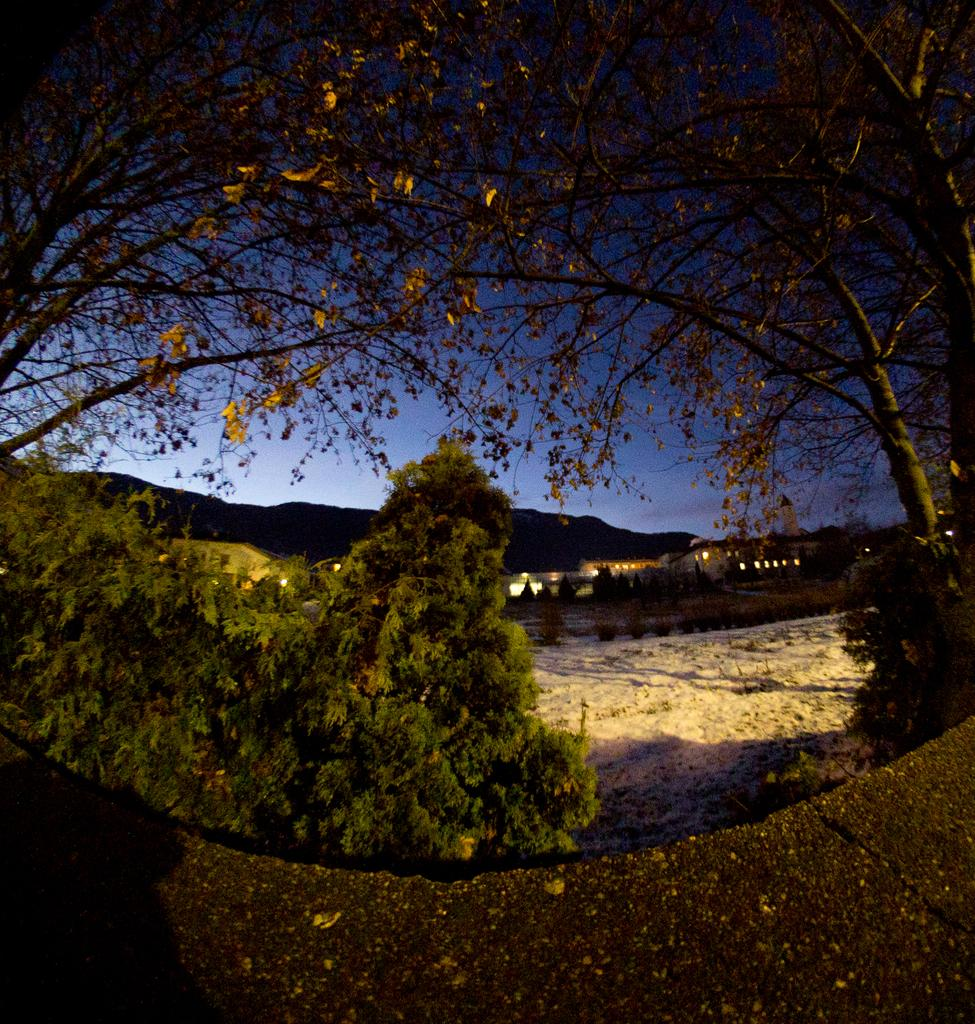What type of vegetation can be seen in the image? There is a plant and trees visible in the image. What structures can be seen in the background of the image? There is a building and lights visible in the background of the image. What natural features are present in the background of the image? There are mountains in the background of the image. What part of the natural environment is visible in the image? The sky is visible in the image, and clouds are present in the sky. What type of creature is interacting with the plant in the image? There is no creature present in the image; it only features a plant, trees, lights, a building, mountains, the sky, and clouds. How many pigs can be seen in the image? There are no pigs present in the image. 